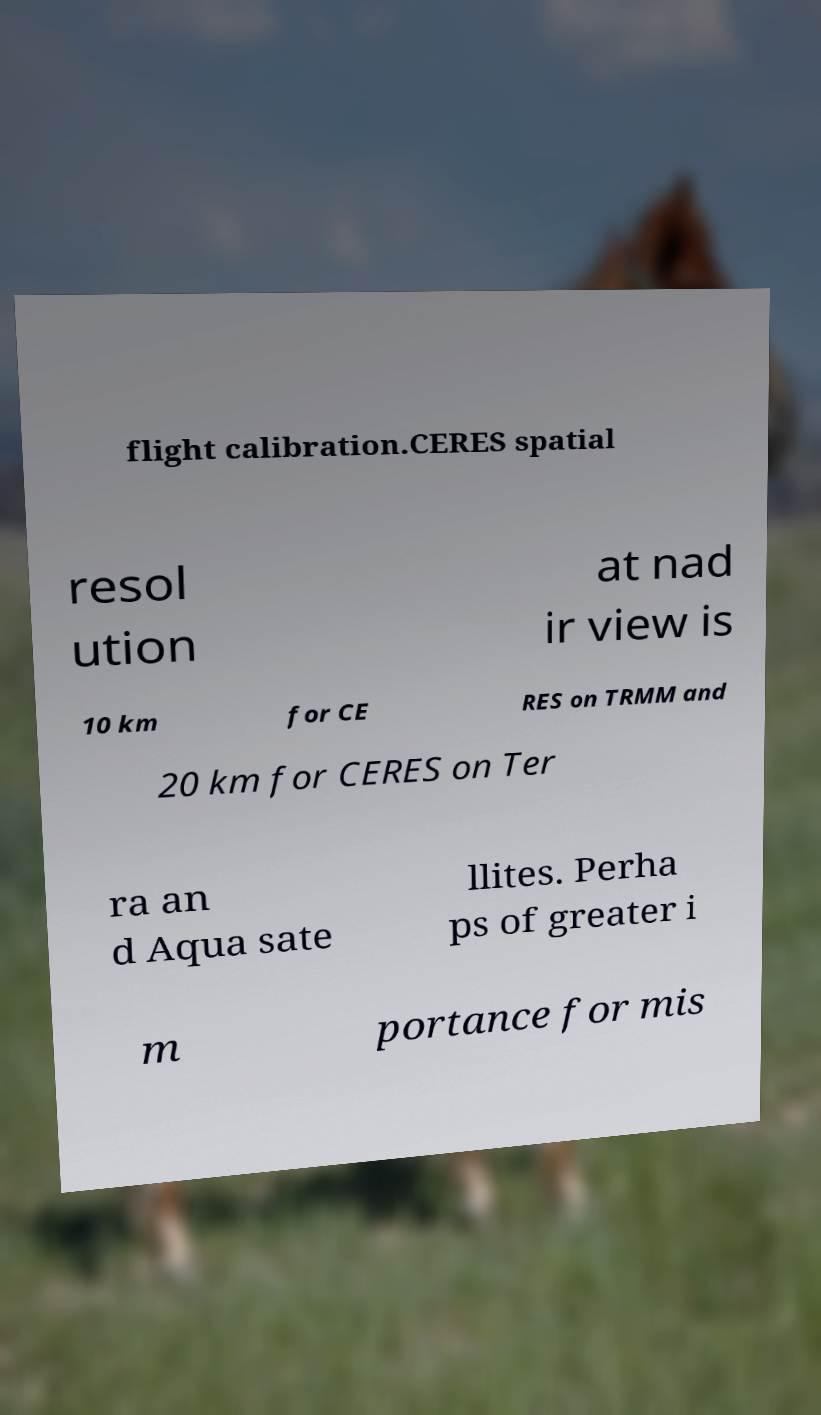I need the written content from this picture converted into text. Can you do that? flight calibration.CERES spatial resol ution at nad ir view is 10 km for CE RES on TRMM and 20 km for CERES on Ter ra an d Aqua sate llites. Perha ps of greater i m portance for mis 